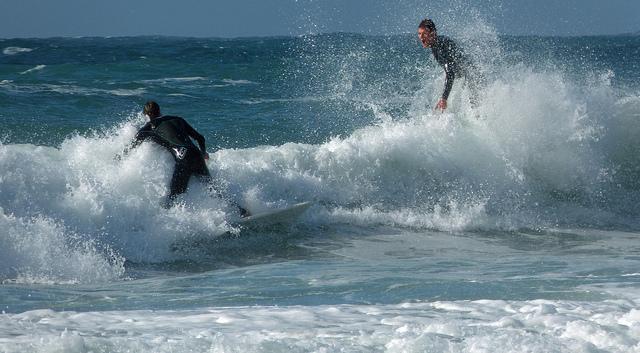Why is the surfer wearing a wetsuit?
Answer the question by selecting the correct answer among the 4 following choices.
Options: Fashion, prevent sunburn, visibility, insulation. Insulation. 